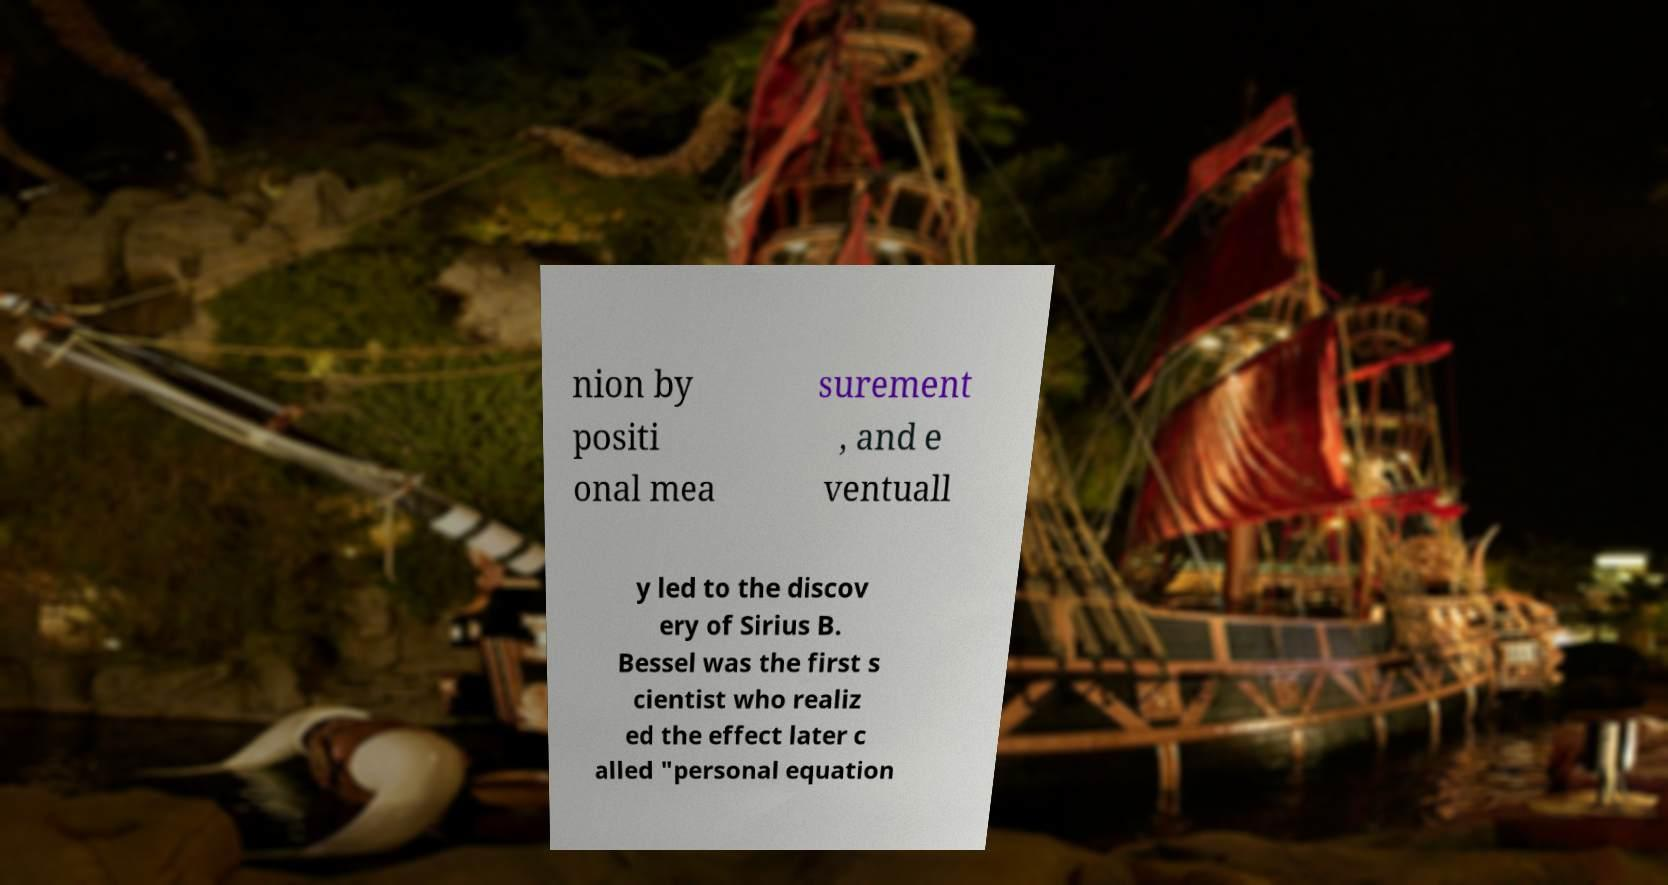For documentation purposes, I need the text within this image transcribed. Could you provide that? nion by positi onal mea surement , and e ventuall y led to the discov ery of Sirius B. Bessel was the first s cientist who realiz ed the effect later c alled "personal equation 